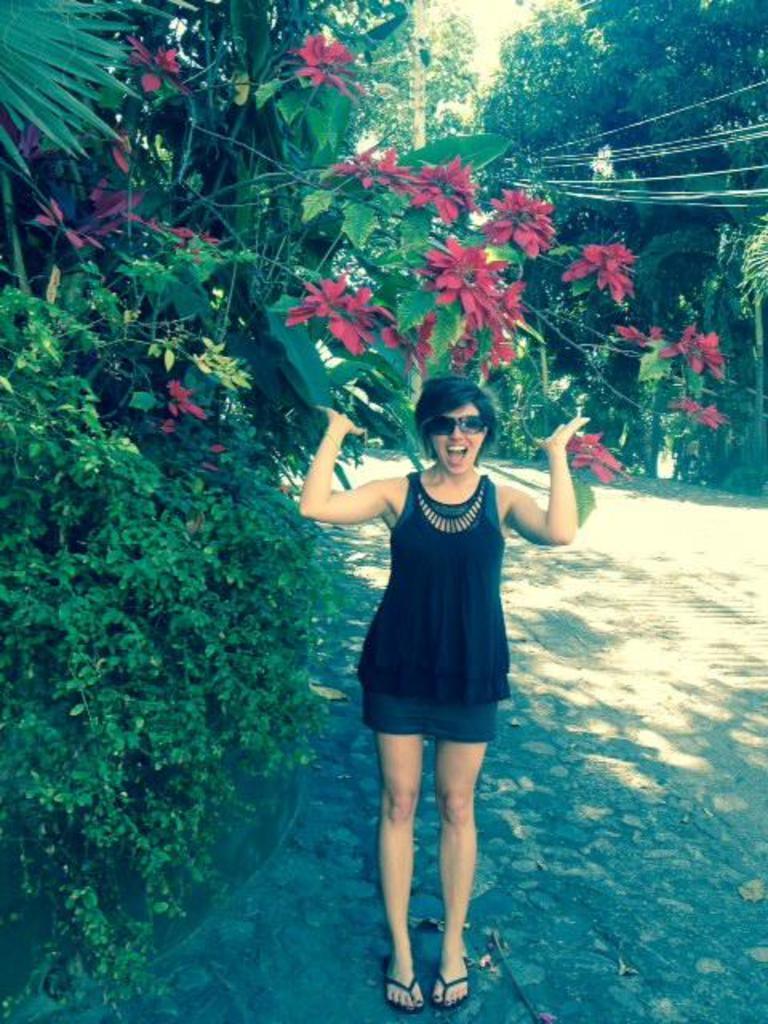Could you give a brief overview of what you see in this image? In this image I can see a woman is standing in the front. I can see she is wearing black colour dress, black shades and black slippers. On the left side and in the background of this image I can see number of trees. I can also see a pole and few wires in the background. 